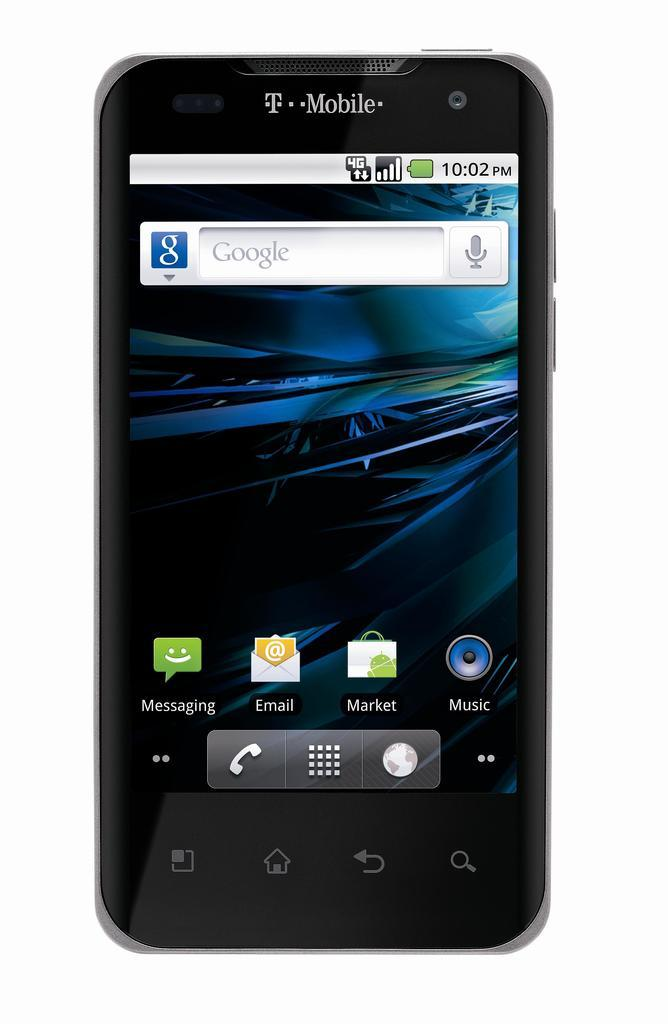<image>
Render a clear and concise summary of the photo. A black cell phone says T Mobile and shows the home screen which has a Google search bar. 